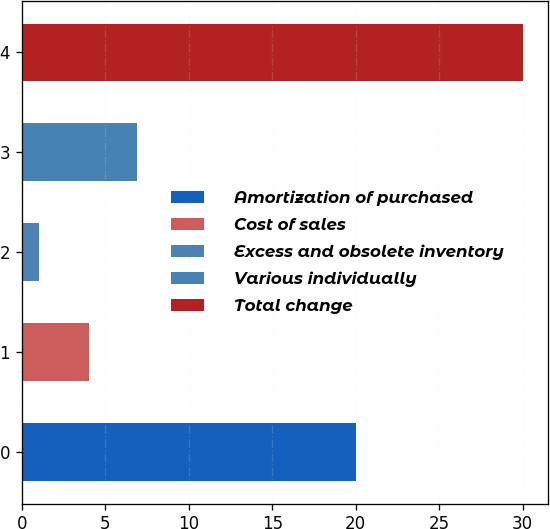<chart> <loc_0><loc_0><loc_500><loc_500><bar_chart><fcel>Amortization of purchased<fcel>Cost of sales<fcel>Excess and obsolete inventory<fcel>Various individually<fcel>Total change<nl><fcel>20<fcel>4<fcel>1<fcel>6.9<fcel>30<nl></chart> 